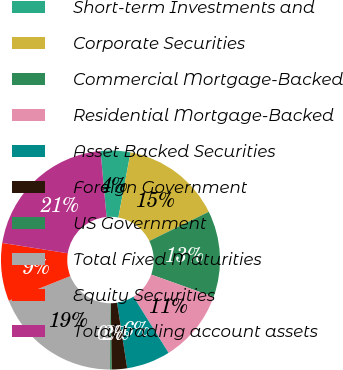<chart> <loc_0><loc_0><loc_500><loc_500><pie_chart><fcel>Short-term Investments and<fcel>Corporate Securities<fcel>Commercial Mortgage-Backed<fcel>Residential Mortgage-Backed<fcel>Asset Backed Securities<fcel>Foreign Government<fcel>US Government<fcel>Total Fixed Maturities<fcel>Equity Securities<fcel>Total trading account assets<nl><fcel>4.38%<fcel>14.81%<fcel>12.72%<fcel>10.64%<fcel>6.46%<fcel>2.29%<fcel>0.21%<fcel>18.88%<fcel>8.55%<fcel>21.06%<nl></chart> 